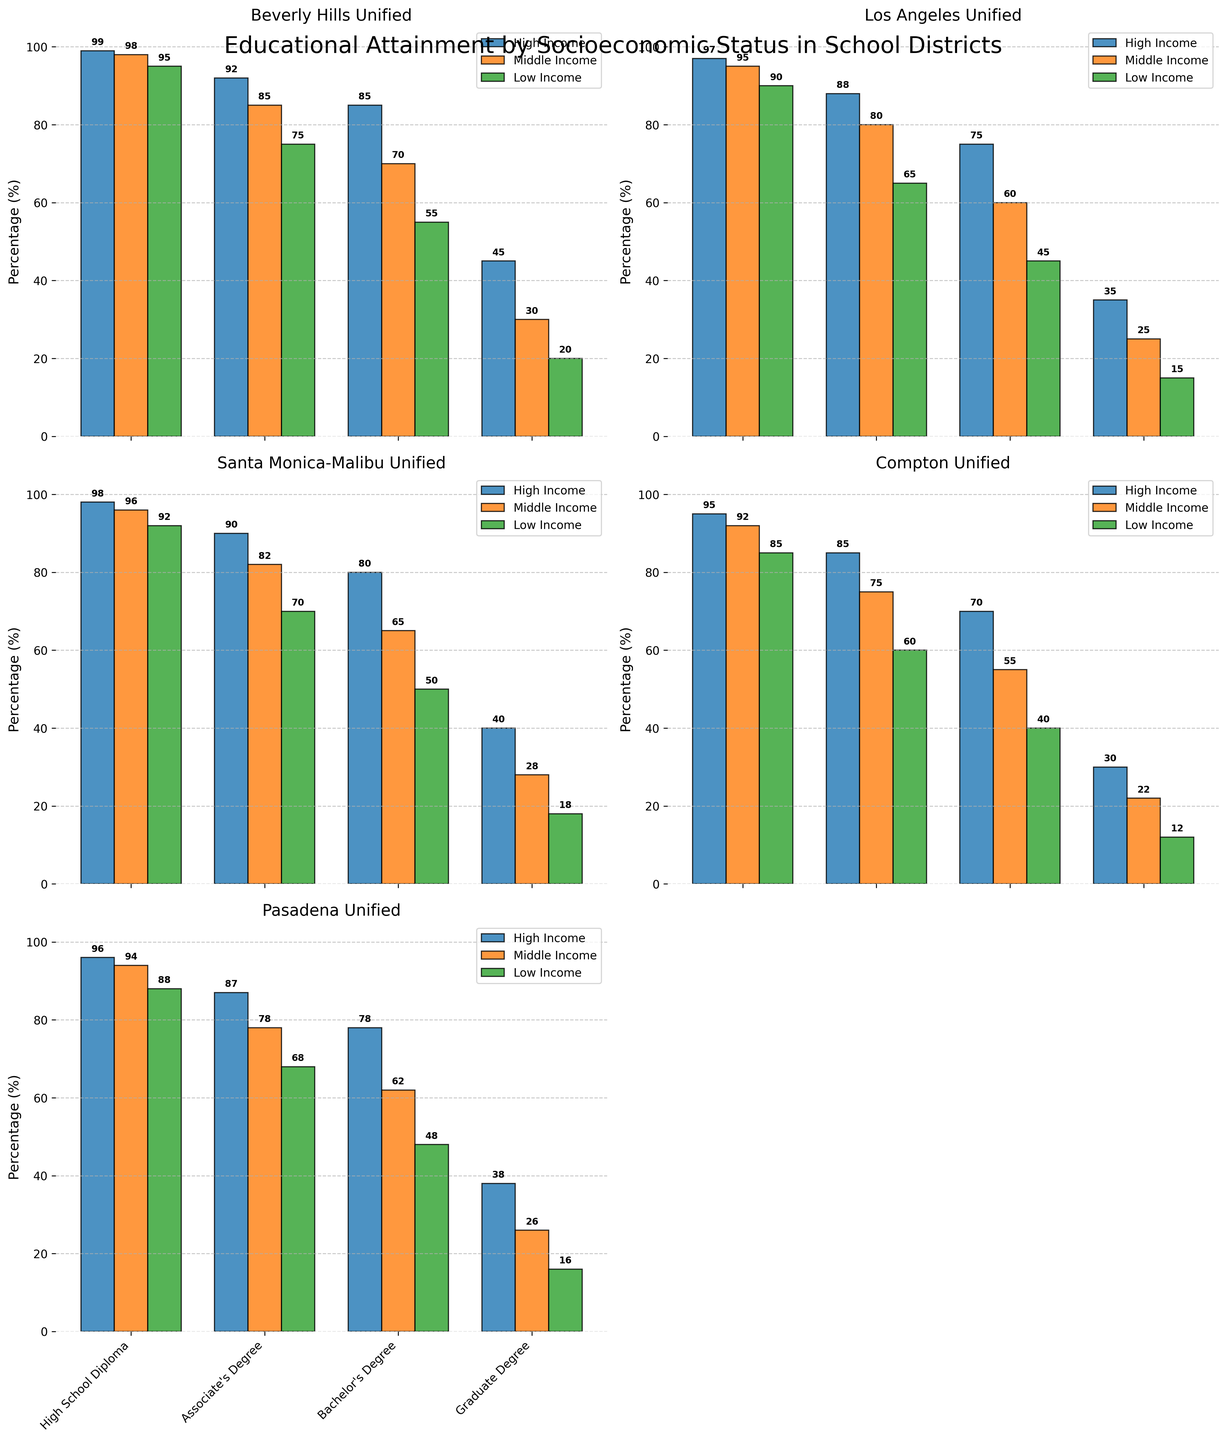How many school districts are depicted in the figure? The figure has multiple subplots, each representing a different school district. Counting each subplot title will indicate the number of school districts.
Answer: 5 Which school district has the highest percentage of Bachelor's Degree attainment among low-income students? By inspecting the percentage bars for Bachelor's Degree attainment among low-income students across different school districts, one can compare these values to find the highest one.
Answer: Beverly Hills Unified What is the difference in Graduate Degree attainment between high-income and low-income students in Los Angeles Unified School District? Look at the Graduate Degree percentage bars for both high-income and low-income students in the Los Angeles Unified School District and calculate the difference.
Answer: 20 Which socioeconomic status consistently shows the lowest educational attainment across all districts? By comparing the bars for each educational level across all districts, it is clear which socioeconomic status is consistently at the bottom for each one.
Answer: Low Income Compare the percentage of students with an Associate's Degree in Beverly Hills Unified for high-income versus middle-income students. Inspect the bars for Associate's Degree attainment in Beverly Hills Unified and compare the high-income percentage with the middle-income percentage.
Answer: High Income: 92, Middle Income: 85 In which district is the gap between high-income and low-income students' High School Diploma attainment the smallest? Calculate the difference between the high-income and low-income students' High School Diploma attainment percentages for each district and compare.
Answer: Compton Unified What is the total percentage of students from middle-income groups attaining at least an Associate's Degree in Santa Monica-Malibu Unified School District? Sum the percentages of students from the middle-income group who attain at least an Associate's Degree (Associate's, Bachelor's, Graduate degrees) in Santa Monica-Malibu Unified.
Answer: 82 + 65 + 28 = 175 Which school district has the highest overall Graduate Degree attainment among its high-income students? Compare the Graduate Degree attainment percentages for high-income students across all the school districts to determine the highest one.
Answer: Beverly Hills Unified What is the combined percentage of High School Diploma attainment among low-income students in the Compton Unified and Pasadena Unified school districts? Add the percentages of High School Diploma attainment among low-income students in Compton Unified and Pasadena Unified school districts.
Answer: 85 + 88 = 173 Which district shows the highest disparity in Bachelor's Degree attainment between high-income and low-income students? Calculate the difference in Bachelor's Degree attainment between high-income and low-income students for each district and identify the highest difference.
Answer: Beverly Hills Unified 